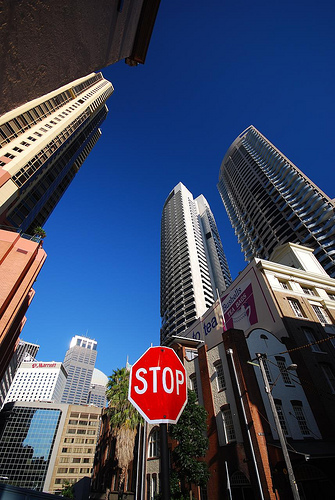Please transcribe the text information in this image. STOP tea 